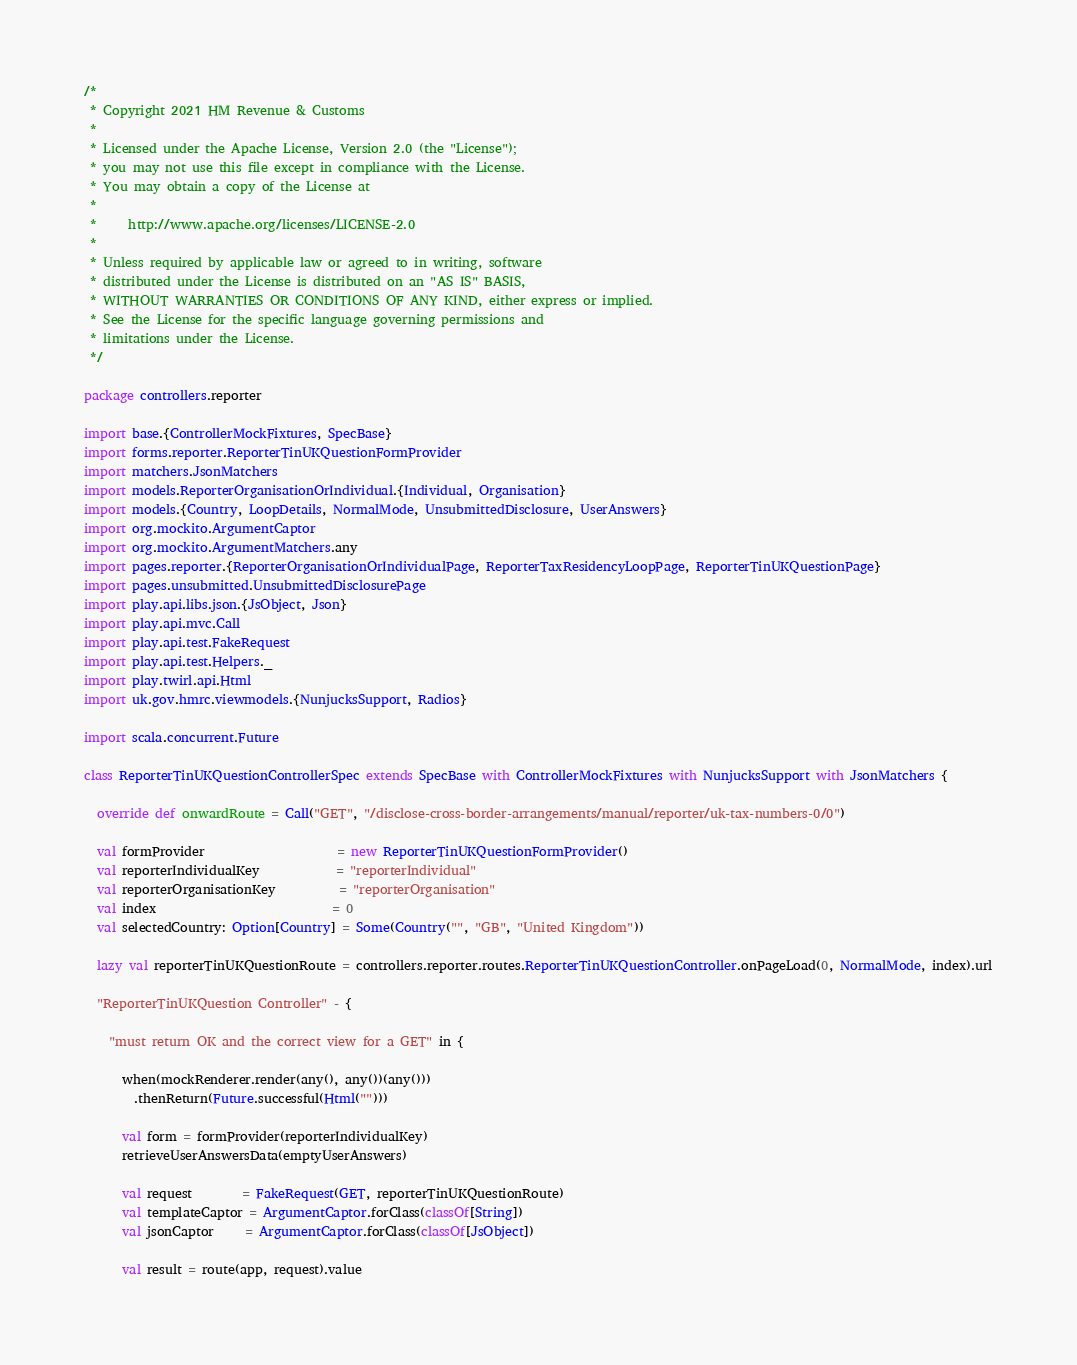<code> <loc_0><loc_0><loc_500><loc_500><_Scala_>/*
 * Copyright 2021 HM Revenue & Customs
 *
 * Licensed under the Apache License, Version 2.0 (the "License");
 * you may not use this file except in compliance with the License.
 * You may obtain a copy of the License at
 *
 *     http://www.apache.org/licenses/LICENSE-2.0
 *
 * Unless required by applicable law or agreed to in writing, software
 * distributed under the License is distributed on an "AS IS" BASIS,
 * WITHOUT WARRANTIES OR CONDITIONS OF ANY KIND, either express or implied.
 * See the License for the specific language governing permissions and
 * limitations under the License.
 */

package controllers.reporter

import base.{ControllerMockFixtures, SpecBase}
import forms.reporter.ReporterTinUKQuestionFormProvider
import matchers.JsonMatchers
import models.ReporterOrganisationOrIndividual.{Individual, Organisation}
import models.{Country, LoopDetails, NormalMode, UnsubmittedDisclosure, UserAnswers}
import org.mockito.ArgumentCaptor
import org.mockito.ArgumentMatchers.any
import pages.reporter.{ReporterOrganisationOrIndividualPage, ReporterTaxResidencyLoopPage, ReporterTinUKQuestionPage}
import pages.unsubmitted.UnsubmittedDisclosurePage
import play.api.libs.json.{JsObject, Json}
import play.api.mvc.Call
import play.api.test.FakeRequest
import play.api.test.Helpers._
import play.twirl.api.Html
import uk.gov.hmrc.viewmodels.{NunjucksSupport, Radios}

import scala.concurrent.Future

class ReporterTinUKQuestionControllerSpec extends SpecBase with ControllerMockFixtures with NunjucksSupport with JsonMatchers {

  override def onwardRoute = Call("GET", "/disclose-cross-border-arrangements/manual/reporter/uk-tax-numbers-0/0")

  val formProvider                     = new ReporterTinUKQuestionFormProvider()
  val reporterIndividualKey            = "reporterIndividual"
  val reporterOrganisationKey          = "reporterOrganisation"
  val index                            = 0
  val selectedCountry: Option[Country] = Some(Country("", "GB", "United Kingdom"))

  lazy val reporterTinUKQuestionRoute = controllers.reporter.routes.ReporterTinUKQuestionController.onPageLoad(0, NormalMode, index).url

  "ReporterTinUKQuestion Controller" - {

    "must return OK and the correct view for a GET" in {

      when(mockRenderer.render(any(), any())(any()))
        .thenReturn(Future.successful(Html("")))

      val form = formProvider(reporterIndividualKey)
      retrieveUserAnswersData(emptyUserAnswers)

      val request        = FakeRequest(GET, reporterTinUKQuestionRoute)
      val templateCaptor = ArgumentCaptor.forClass(classOf[String])
      val jsonCaptor     = ArgumentCaptor.forClass(classOf[JsObject])

      val result = route(app, request).value
</code> 